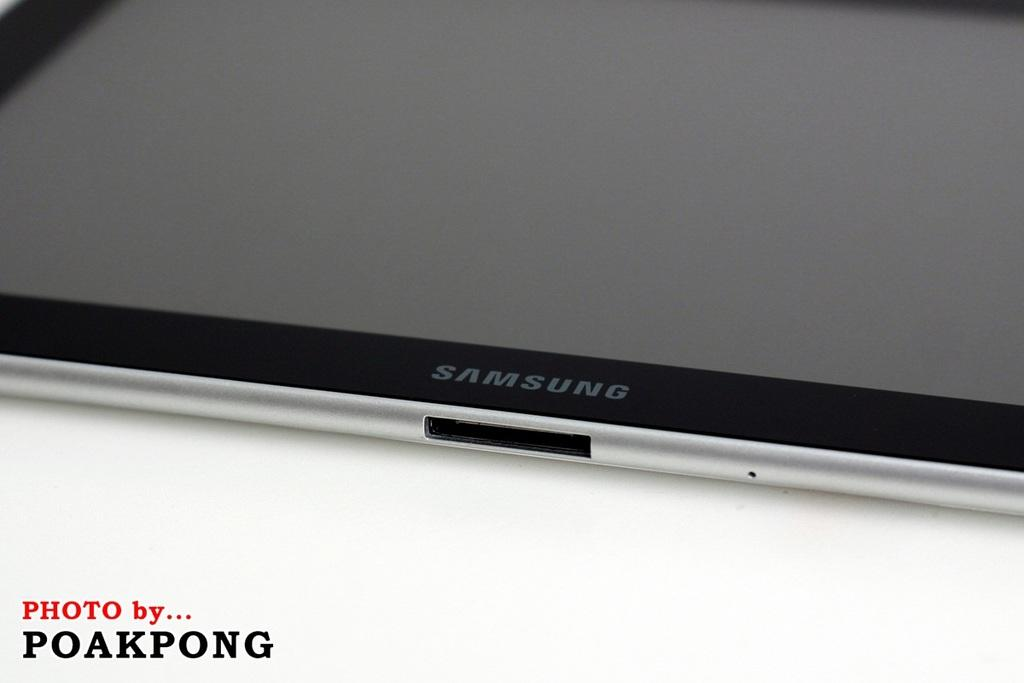<image>
Write a terse but informative summary of the picture. The bottom of a Samsung tablet showing an input jack and micropone hole in the bezel. 